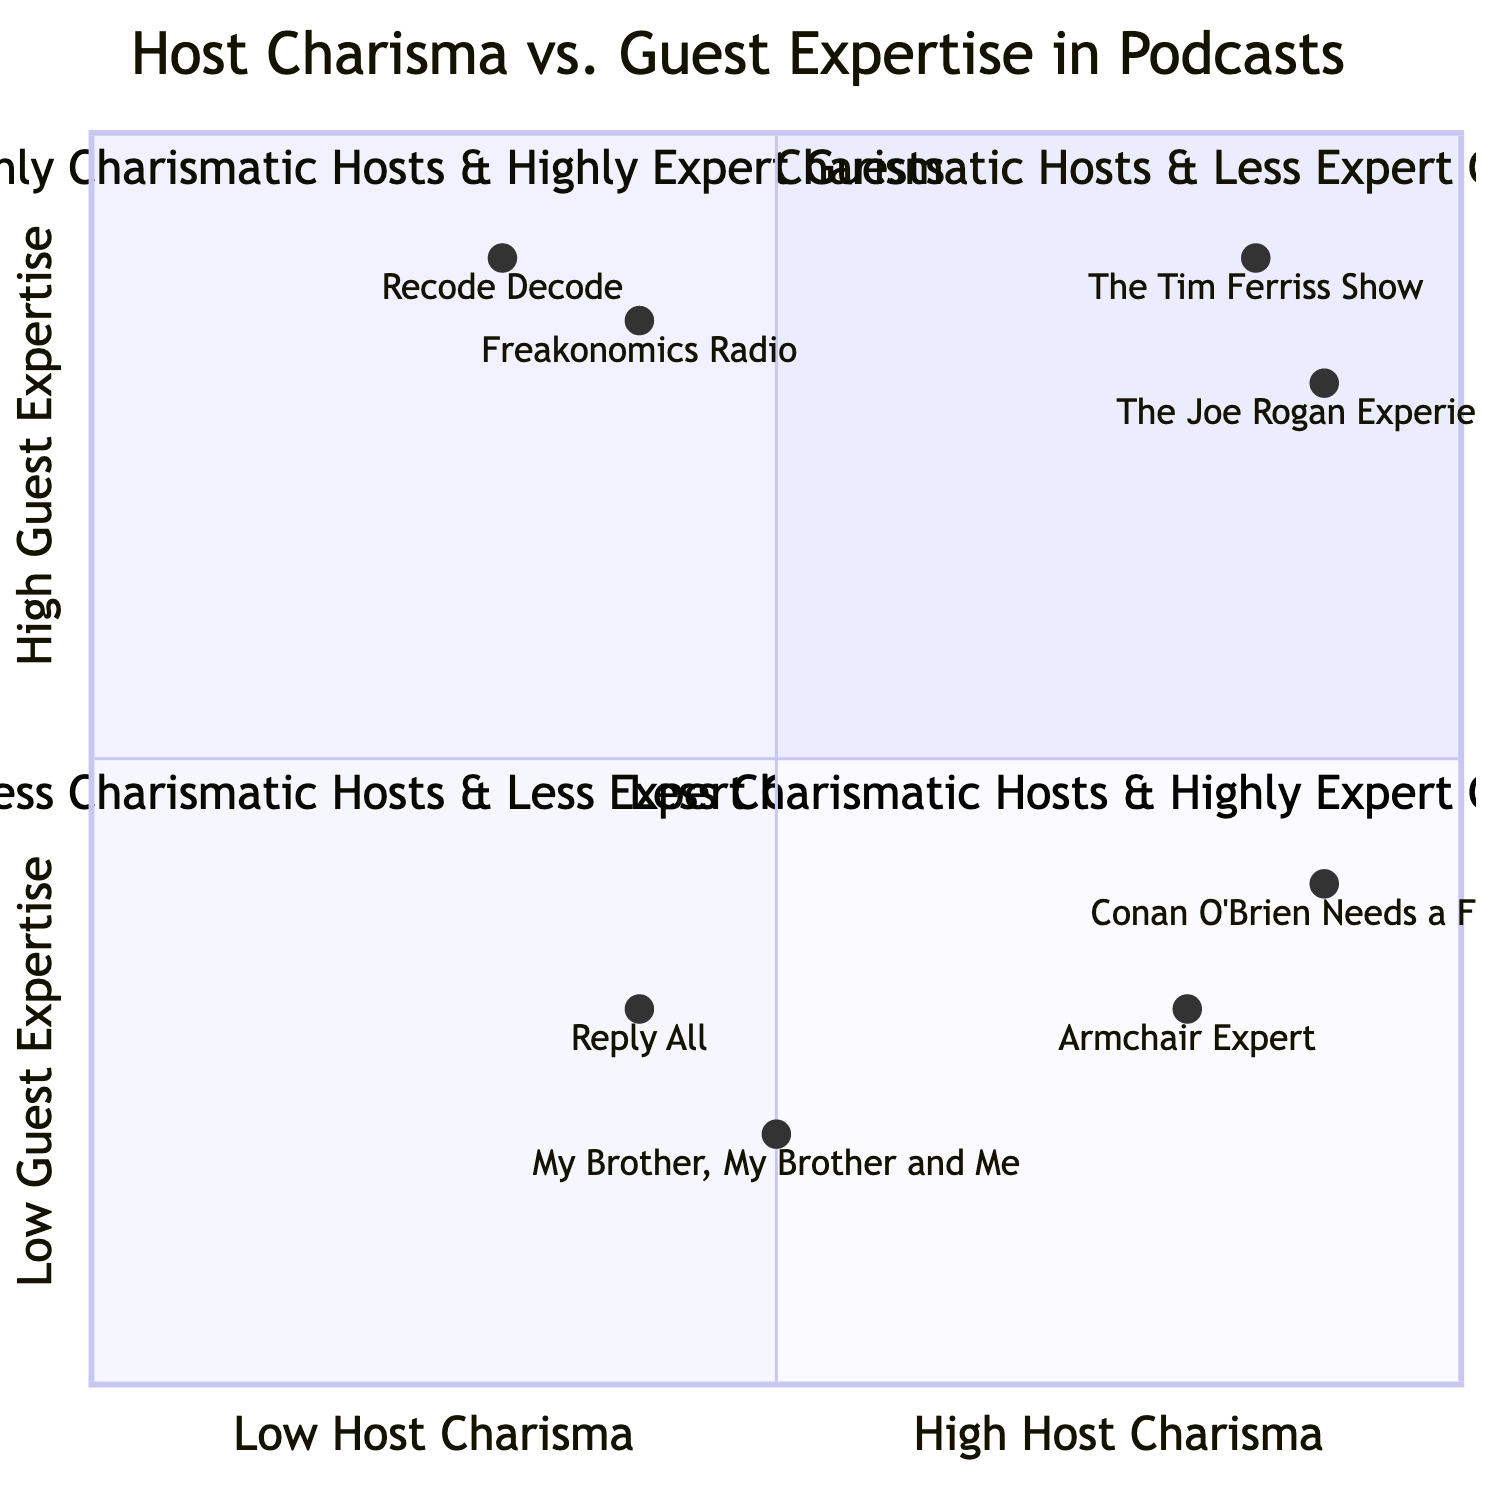What is the quadrant for "The Joe Rogan Experience"? The podcast "The Joe Rogan Experience" is located at the coordinates [0.9, 0.8]. Since it has high host charisma and high guest expertise, it falls into the Upper Right quadrant, labeled "Highly Charismatic Hosts & Highly Expert Guests."
Answer: Highly Charismatic Hosts & Highly Expert Guests How many podcasts are situated in the Lower Left quadrant? In the Lower Left quadrant, which is labeled "Less Charismatic Hosts & Less Expert Guests," there are two podcasts listed: "Reply All" and "My Brother, My Brother and Me." Thus, the count is two.
Answer: 2 Which podcast has the highest guest expertise according to the chart? The podcast "The Tim Ferriss Show" features a guest with high expertise, specifically Ray Dalio, as indicated by its placement [0.85, 0.9]. This makes it the podcast representing the highest guest expertise.
Answer: The Tim Ferriss Show What is the x-axis value for "Armchair Expert"? The coordinates for "Armchair Expert" are [0.8, 0.3]. The first value indicates host charisma, so the x-axis value is 0.8.
Answer: 0.8 Which host is associated with the podcast that falls in the "Less Charismatic Hosts & Highly Expert Guests" quadrant? In the Lower Right quadrant, titled "Less Charismatic Hosts & Highly Expert Guests," the podcast "Recode Decode" is listed, and the host is Kara Swisher.
Answer: Kara Swisher How do "Freakonomics Radio" and "Recode Decode" compare in terms of guest expertise? "Freakonomics Radio" has a guest expertise value of 0.85, while "Recode Decode" has a guest expertise value of 0.9. Therefore, although both are high, "Recode Decode" has a slightly higher value.
Answer: Recode Decode has higher guest expertise What is the title of the quadrant containing "My Brother, My Brother and Me"? "My Brother, My Brother and Me" is located in the Lower Left quadrant titled "Less Charismatic Hosts & Less Expert Guests."
Answer: Less Charismatic Hosts & Less Expert Guests Which podcast is on the border of high host charisma and low guest expertise? The podcast "Armchair Expert," which features Dax Shepard as the host, is placed closer to the high host charisma side at [0.8, 0.3] but in the quadrant where guest expertise is lower, specifically "Highly Charismatic Hosts & Less Expert Guests."
Answer: Armchair Expert 